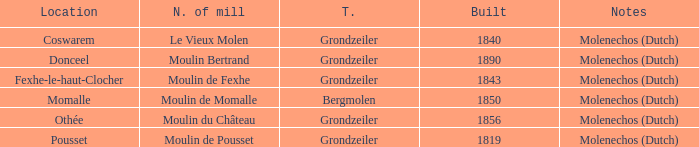What is the Location of the Moulin Bertrand Mill? Donceel. 